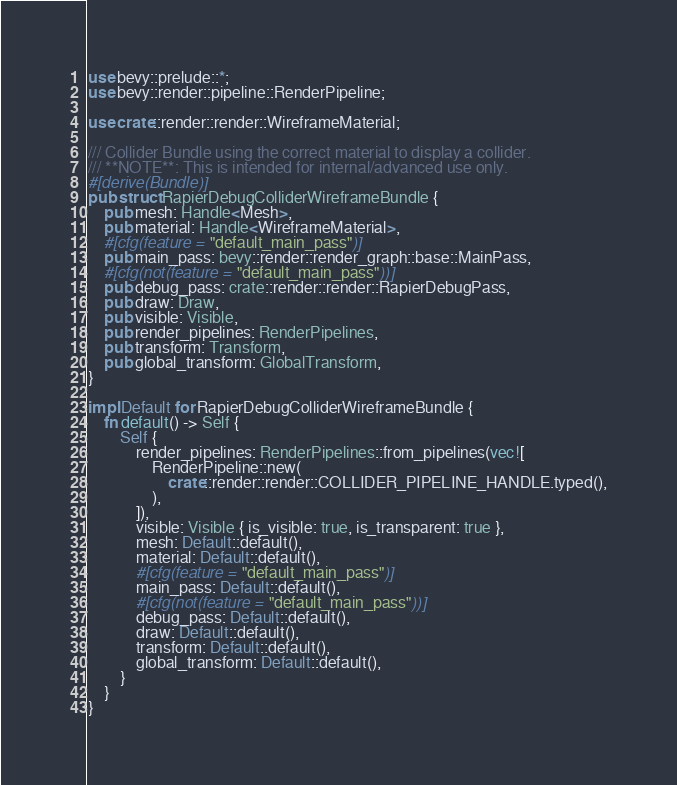<code> <loc_0><loc_0><loc_500><loc_500><_Rust_>use bevy::prelude::*;
use bevy::render::pipeline::RenderPipeline;

use crate::render::render::WireframeMaterial;

/// Collider Bundle using the correct material to display a collider.
/// **NOTE**: This is intended for internal/advanced use only.
#[derive(Bundle)]
pub struct RapierDebugColliderWireframeBundle {
    pub mesh: Handle<Mesh>,
    pub material: Handle<WireframeMaterial>,
    #[cfg(feature = "default_main_pass")]
    pub main_pass: bevy::render::render_graph::base::MainPass,
    #[cfg(not(feature = "default_main_pass"))]
    pub debug_pass: crate::render::render::RapierDebugPass,
    pub draw: Draw,
    pub visible: Visible,
    pub render_pipelines: RenderPipelines,
    pub transform: Transform,
    pub global_transform: GlobalTransform,
}

impl Default for RapierDebugColliderWireframeBundle {
    fn default() -> Self {
        Self {
            render_pipelines: RenderPipelines::from_pipelines(vec![
                RenderPipeline::new(
                    crate::render::render::COLLIDER_PIPELINE_HANDLE.typed(),
                ),
            ]),
            visible: Visible { is_visible: true, is_transparent: true },
            mesh: Default::default(),
            material: Default::default(),
            #[cfg(feature = "default_main_pass")]
            main_pass: Default::default(),
            #[cfg(not(feature = "default_main_pass"))]
            debug_pass: Default::default(),
            draw: Default::default(),
            transform: Default::default(),
            global_transform: Default::default(),
        }
    }
}
</code> 